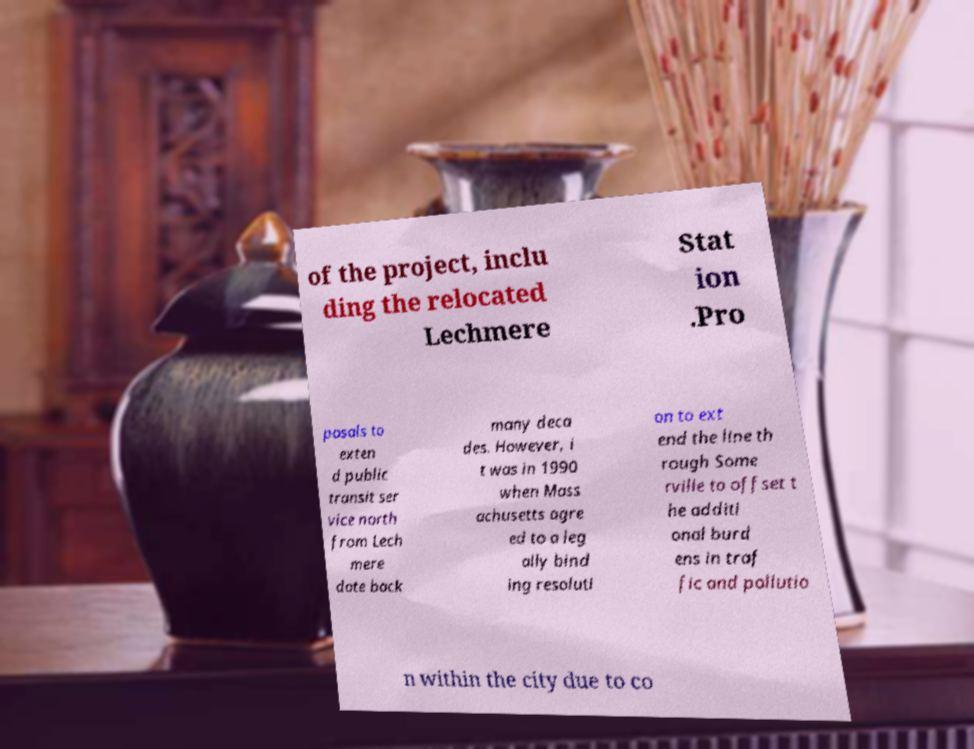Can you read and provide the text displayed in the image?This photo seems to have some interesting text. Can you extract and type it out for me? of the project, inclu ding the relocated Lechmere Stat ion .Pro posals to exten d public transit ser vice north from Lech mere date back many deca des. However, i t was in 1990 when Mass achusetts agre ed to a leg ally bind ing resoluti on to ext end the line th rough Some rville to offset t he additi onal burd ens in traf fic and pollutio n within the city due to co 